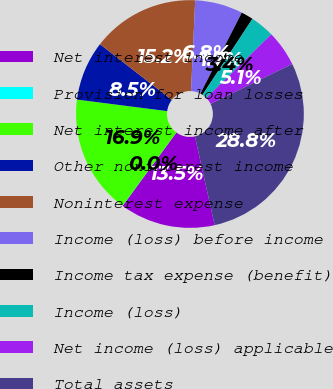<chart> <loc_0><loc_0><loc_500><loc_500><pie_chart><fcel>Net interest income<fcel>Provision for loan losses<fcel>Net interest income after<fcel>Other noninterest income<fcel>Noninterest expense<fcel>Income (loss) before income<fcel>Income tax expense (benefit)<fcel>Income (loss)<fcel>Net income (loss) applicable<fcel>Total assets<nl><fcel>13.55%<fcel>0.03%<fcel>16.93%<fcel>8.48%<fcel>15.24%<fcel>6.79%<fcel>1.72%<fcel>3.41%<fcel>5.1%<fcel>28.76%<nl></chart> 